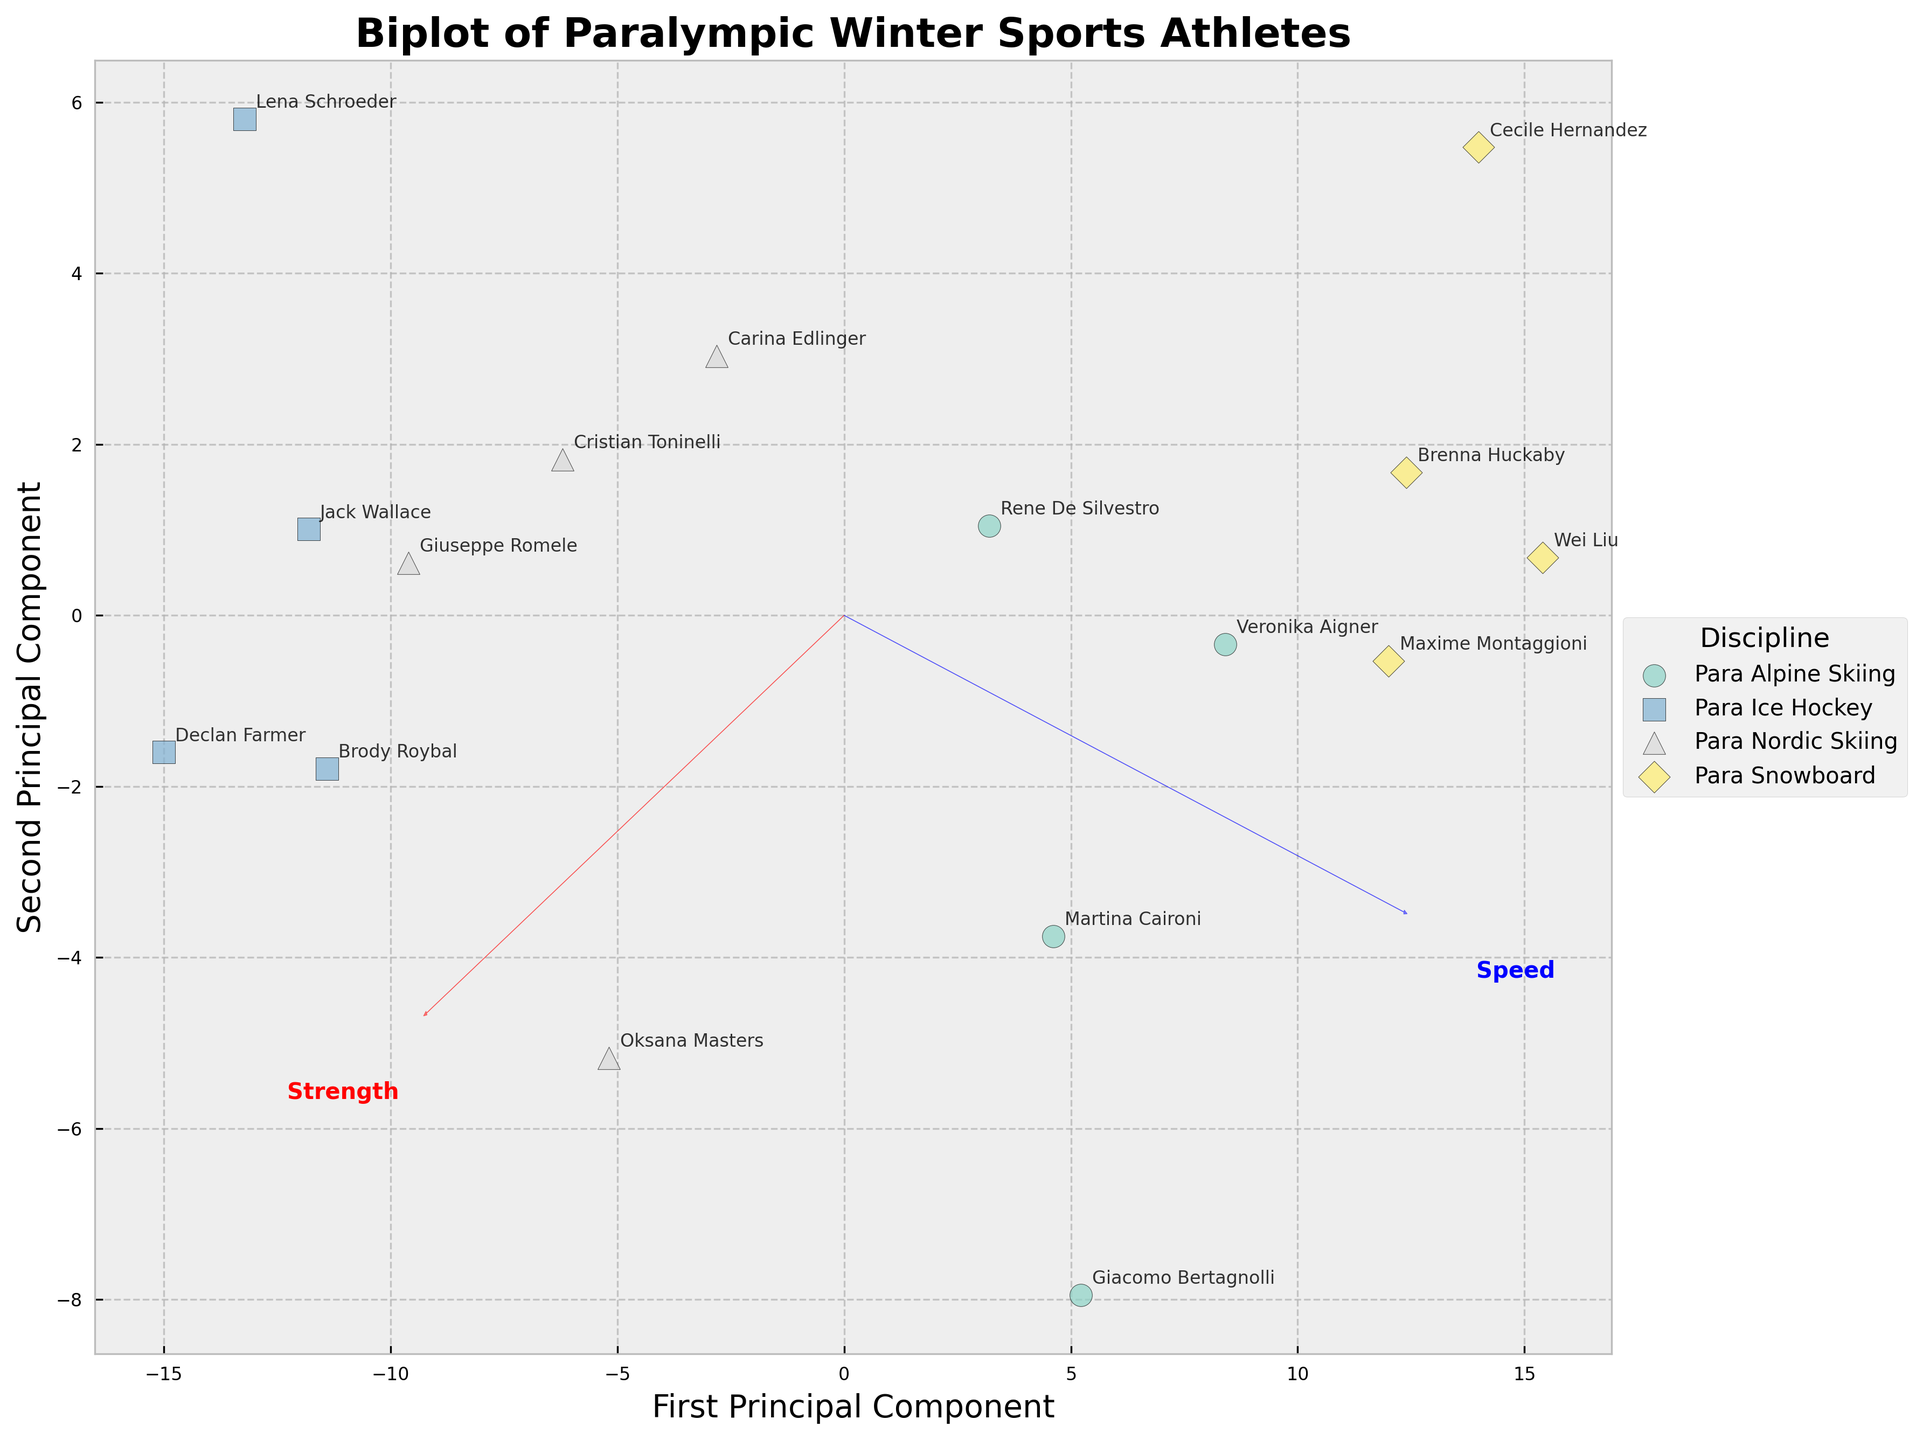What's the title of the figure? The title of the figure is prominently displayed at the top of the plot. It helps to understand what the plot represents.
Answer: Biplot of Paralympic Winter Sports Athletes Which athlete in Para Ice Hockey has the highest speed? To find this, locate the Para Ice Hockey group on the plot, identify the athlete with the highest Speed score amongst them from the annotations.
Answer: Jack Wallace How are the disciplines distinguished in the plot? The disciplines are distinguished by different colors and marker shapes. Each discipline has its unique color and marker shape as indicated in the legend.
Answer: By colors and marker shapes Which principal component corresponds most closely to the Strength variable? Look at the direction of the arrow labeled "Strength" and see which principal component (x or y) it is most aligned with. The arrow closest to the x-axis pointing will indicate this alignment.
Answer: First Principal Component What is the PCA analysis used for in this plot? PCA is used to reduce the dimensionality of data, projecting it onto a lower-dimensional space while preserving the variance as much as possible. The plot shows athletes plotted on the first two principal components.
Answer: Dimensionality reduction Which discipline has athletes with the highest combined strength and speed scores on average? Calculate the average combined strength and speed scores for each discipline. Look at the overall spread and clusters of disciplines in the plot and the average vector positions.
Answer: Para Alpine Skiing Which two athletes from different disciplines are closest to each other in the plot? Observe the plot and find two data points from different disciplines that are closest. Use the athlete names annotated near the points to identify them.
Answer: Giuseppe Romele and Martina Caironi Is there a clear separation between athletes from different disciplines? Look at the clusters and how distinct they are. If points from different disciplines are clearly separated by distance and grouping, there is clear separation.
Answer: Not completely clear What does a longer arrow in the biplot represent? Longer arrows indicate that the corresponding variable (Strength or Speed) has a greater contribution to the variance explained by the principal components. Compare arrow lengths to verify this.
Answer: Greater contribution to variance Which feature (Strength or Speed) seems to be more important in distinguishing between Para Ice Hockey and Para Snowboard athletes? Compare the directions and lengths of the arrows for Strength and Speed relative to clusters of Para Ice Hockey and Para Snowboard athletes. Consider which arrow differentiates the clusters more distinctly.
Answer: Speed 